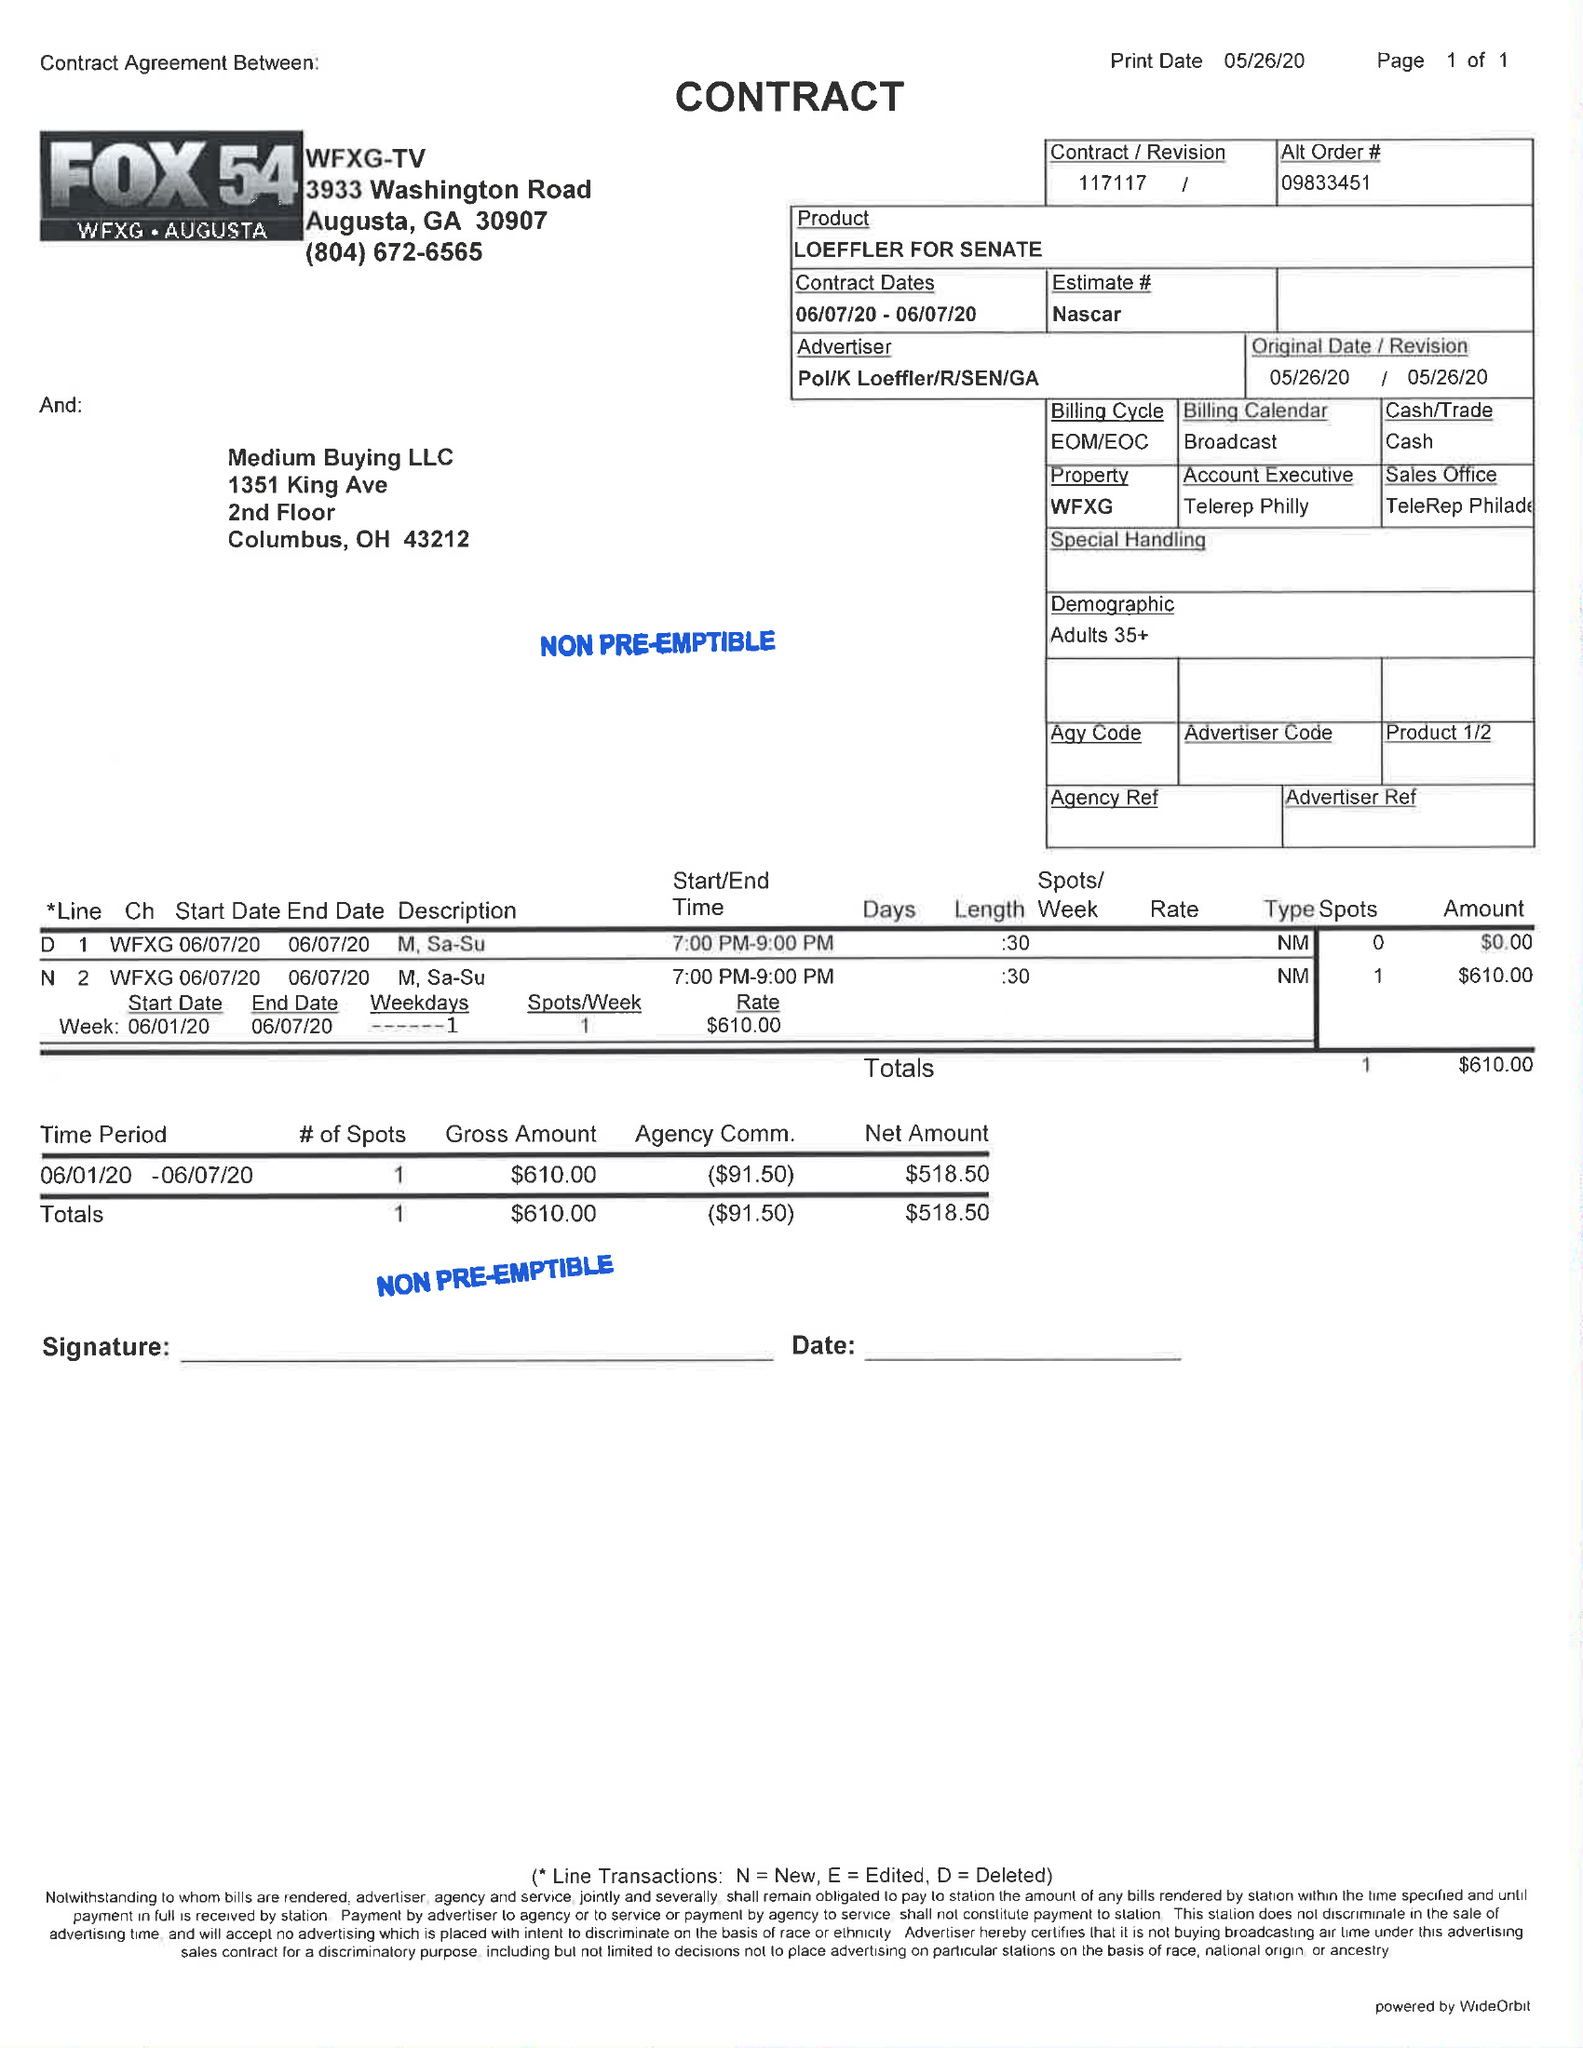What is the value for the flight_from?
Answer the question using a single word or phrase. 06/07/20 